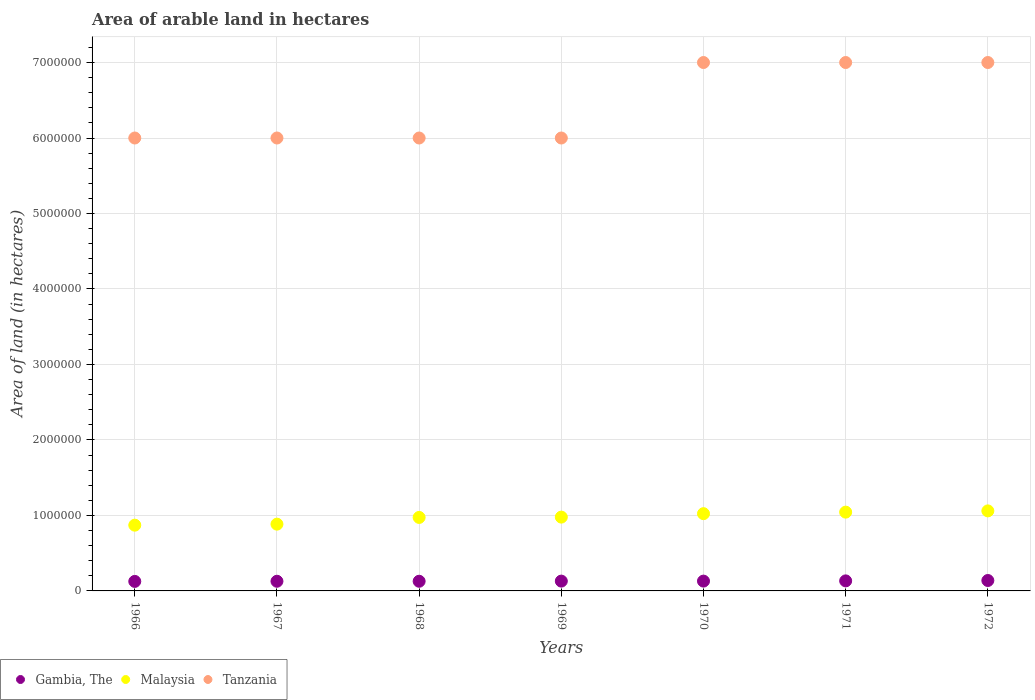How many different coloured dotlines are there?
Provide a short and direct response. 3. Is the number of dotlines equal to the number of legend labels?
Give a very brief answer. Yes. What is the total arable land in Tanzania in 1970?
Provide a succinct answer. 7.00e+06. Across all years, what is the maximum total arable land in Tanzania?
Offer a terse response. 7.00e+06. Across all years, what is the minimum total arable land in Malaysia?
Give a very brief answer. 8.71e+05. In which year was the total arable land in Gambia, The maximum?
Provide a succinct answer. 1972. In which year was the total arable land in Tanzania minimum?
Make the answer very short. 1966. What is the total total arable land in Malaysia in the graph?
Make the answer very short. 6.83e+06. What is the difference between the total arable land in Gambia, The in 1969 and that in 1971?
Keep it short and to the point. -3000. What is the difference between the total arable land in Gambia, The in 1967 and the total arable land in Tanzania in 1968?
Give a very brief answer. -5.87e+06. What is the average total arable land in Tanzania per year?
Ensure brevity in your answer.  6.43e+06. In the year 1971, what is the difference between the total arable land in Gambia, The and total arable land in Tanzania?
Your answer should be very brief. -6.87e+06. In how many years, is the total arable land in Gambia, The greater than 400000 hectares?
Offer a very short reply. 0. What is the ratio of the total arable land in Tanzania in 1968 to that in 1972?
Your answer should be compact. 0.86. Is the total arable land in Malaysia in 1967 less than that in 1971?
Offer a very short reply. Yes. Is the difference between the total arable land in Gambia, The in 1966 and 1971 greater than the difference between the total arable land in Tanzania in 1966 and 1971?
Give a very brief answer. Yes. What is the difference between the highest and the lowest total arable land in Malaysia?
Provide a short and direct response. 1.89e+05. In how many years, is the total arable land in Malaysia greater than the average total arable land in Malaysia taken over all years?
Ensure brevity in your answer.  4. Is it the case that in every year, the sum of the total arable land in Tanzania and total arable land in Malaysia  is greater than the total arable land in Gambia, The?
Your response must be concise. Yes. Is the total arable land in Malaysia strictly greater than the total arable land in Gambia, The over the years?
Provide a succinct answer. Yes. How many dotlines are there?
Give a very brief answer. 3. Does the graph contain any zero values?
Your response must be concise. No. Does the graph contain grids?
Keep it short and to the point. Yes. How are the legend labels stacked?
Provide a short and direct response. Horizontal. What is the title of the graph?
Make the answer very short. Area of arable land in hectares. What is the label or title of the X-axis?
Your answer should be compact. Years. What is the label or title of the Y-axis?
Ensure brevity in your answer.  Area of land (in hectares). What is the Area of land (in hectares) in Gambia, The in 1966?
Keep it short and to the point. 1.26e+05. What is the Area of land (in hectares) of Malaysia in 1966?
Keep it short and to the point. 8.71e+05. What is the Area of land (in hectares) in Tanzania in 1966?
Your response must be concise. 6.00e+06. What is the Area of land (in hectares) of Gambia, The in 1967?
Your answer should be compact. 1.28e+05. What is the Area of land (in hectares) in Malaysia in 1967?
Provide a succinct answer. 8.84e+05. What is the Area of land (in hectares) of Tanzania in 1967?
Your answer should be very brief. 6.00e+06. What is the Area of land (in hectares) of Gambia, The in 1968?
Your answer should be compact. 1.28e+05. What is the Area of land (in hectares) in Malaysia in 1968?
Your answer should be compact. 9.74e+05. What is the Area of land (in hectares) of Malaysia in 1969?
Ensure brevity in your answer.  9.78e+05. What is the Area of land (in hectares) of Gambia, The in 1970?
Offer a terse response. 1.30e+05. What is the Area of land (in hectares) in Malaysia in 1970?
Make the answer very short. 1.02e+06. What is the Area of land (in hectares) in Gambia, The in 1971?
Your answer should be compact. 1.33e+05. What is the Area of land (in hectares) in Malaysia in 1971?
Offer a very short reply. 1.04e+06. What is the Area of land (in hectares) in Gambia, The in 1972?
Give a very brief answer. 1.38e+05. What is the Area of land (in hectares) of Malaysia in 1972?
Give a very brief answer. 1.06e+06. Across all years, what is the maximum Area of land (in hectares) of Gambia, The?
Your answer should be compact. 1.38e+05. Across all years, what is the maximum Area of land (in hectares) of Malaysia?
Make the answer very short. 1.06e+06. Across all years, what is the maximum Area of land (in hectares) of Tanzania?
Give a very brief answer. 7.00e+06. Across all years, what is the minimum Area of land (in hectares) of Gambia, The?
Provide a succinct answer. 1.26e+05. Across all years, what is the minimum Area of land (in hectares) in Malaysia?
Keep it short and to the point. 8.71e+05. What is the total Area of land (in hectares) in Gambia, The in the graph?
Ensure brevity in your answer.  9.13e+05. What is the total Area of land (in hectares) of Malaysia in the graph?
Offer a terse response. 6.83e+06. What is the total Area of land (in hectares) in Tanzania in the graph?
Your response must be concise. 4.50e+07. What is the difference between the Area of land (in hectares) of Gambia, The in 1966 and that in 1967?
Ensure brevity in your answer.  -2000. What is the difference between the Area of land (in hectares) of Malaysia in 1966 and that in 1967?
Provide a succinct answer. -1.34e+04. What is the difference between the Area of land (in hectares) of Tanzania in 1966 and that in 1967?
Your answer should be very brief. 0. What is the difference between the Area of land (in hectares) of Gambia, The in 1966 and that in 1968?
Make the answer very short. -2000. What is the difference between the Area of land (in hectares) of Malaysia in 1966 and that in 1968?
Your response must be concise. -1.02e+05. What is the difference between the Area of land (in hectares) in Gambia, The in 1966 and that in 1969?
Offer a terse response. -4000. What is the difference between the Area of land (in hectares) in Malaysia in 1966 and that in 1969?
Provide a succinct answer. -1.07e+05. What is the difference between the Area of land (in hectares) of Tanzania in 1966 and that in 1969?
Offer a terse response. 0. What is the difference between the Area of land (in hectares) of Gambia, The in 1966 and that in 1970?
Make the answer very short. -4000. What is the difference between the Area of land (in hectares) of Malaysia in 1966 and that in 1970?
Offer a terse response. -1.52e+05. What is the difference between the Area of land (in hectares) in Gambia, The in 1966 and that in 1971?
Provide a short and direct response. -7000. What is the difference between the Area of land (in hectares) in Malaysia in 1966 and that in 1971?
Offer a very short reply. -1.73e+05. What is the difference between the Area of land (in hectares) of Gambia, The in 1966 and that in 1972?
Ensure brevity in your answer.  -1.20e+04. What is the difference between the Area of land (in hectares) in Malaysia in 1966 and that in 1972?
Ensure brevity in your answer.  -1.89e+05. What is the difference between the Area of land (in hectares) in Malaysia in 1967 and that in 1968?
Your answer should be very brief. -8.91e+04. What is the difference between the Area of land (in hectares) of Gambia, The in 1967 and that in 1969?
Provide a short and direct response. -2000. What is the difference between the Area of land (in hectares) in Malaysia in 1967 and that in 1969?
Your response must be concise. -9.33e+04. What is the difference between the Area of land (in hectares) in Gambia, The in 1967 and that in 1970?
Give a very brief answer. -2000. What is the difference between the Area of land (in hectares) of Malaysia in 1967 and that in 1970?
Provide a succinct answer. -1.39e+05. What is the difference between the Area of land (in hectares) in Gambia, The in 1967 and that in 1971?
Your answer should be compact. -5000. What is the difference between the Area of land (in hectares) in Malaysia in 1967 and that in 1971?
Ensure brevity in your answer.  -1.59e+05. What is the difference between the Area of land (in hectares) of Tanzania in 1967 and that in 1971?
Your response must be concise. -1.00e+06. What is the difference between the Area of land (in hectares) in Malaysia in 1967 and that in 1972?
Your response must be concise. -1.76e+05. What is the difference between the Area of land (in hectares) of Gambia, The in 1968 and that in 1969?
Ensure brevity in your answer.  -2000. What is the difference between the Area of land (in hectares) of Malaysia in 1968 and that in 1969?
Keep it short and to the point. -4200. What is the difference between the Area of land (in hectares) of Gambia, The in 1968 and that in 1970?
Ensure brevity in your answer.  -2000. What is the difference between the Area of land (in hectares) of Malaysia in 1968 and that in 1970?
Provide a succinct answer. -4.98e+04. What is the difference between the Area of land (in hectares) of Tanzania in 1968 and that in 1970?
Provide a short and direct response. -1.00e+06. What is the difference between the Area of land (in hectares) in Gambia, The in 1968 and that in 1971?
Offer a very short reply. -5000. What is the difference between the Area of land (in hectares) in Malaysia in 1968 and that in 1971?
Provide a succinct answer. -7.01e+04. What is the difference between the Area of land (in hectares) in Malaysia in 1968 and that in 1972?
Your answer should be very brief. -8.66e+04. What is the difference between the Area of land (in hectares) of Tanzania in 1968 and that in 1972?
Provide a short and direct response. -1.00e+06. What is the difference between the Area of land (in hectares) in Gambia, The in 1969 and that in 1970?
Keep it short and to the point. 0. What is the difference between the Area of land (in hectares) of Malaysia in 1969 and that in 1970?
Your answer should be compact. -4.56e+04. What is the difference between the Area of land (in hectares) in Tanzania in 1969 and that in 1970?
Make the answer very short. -1.00e+06. What is the difference between the Area of land (in hectares) in Gambia, The in 1969 and that in 1971?
Your response must be concise. -3000. What is the difference between the Area of land (in hectares) of Malaysia in 1969 and that in 1971?
Provide a succinct answer. -6.59e+04. What is the difference between the Area of land (in hectares) of Gambia, The in 1969 and that in 1972?
Make the answer very short. -8000. What is the difference between the Area of land (in hectares) of Malaysia in 1969 and that in 1972?
Offer a terse response. -8.24e+04. What is the difference between the Area of land (in hectares) in Gambia, The in 1970 and that in 1971?
Give a very brief answer. -3000. What is the difference between the Area of land (in hectares) of Malaysia in 1970 and that in 1971?
Provide a short and direct response. -2.03e+04. What is the difference between the Area of land (in hectares) in Gambia, The in 1970 and that in 1972?
Your answer should be compact. -8000. What is the difference between the Area of land (in hectares) of Malaysia in 1970 and that in 1972?
Your response must be concise. -3.68e+04. What is the difference between the Area of land (in hectares) of Gambia, The in 1971 and that in 1972?
Keep it short and to the point. -5000. What is the difference between the Area of land (in hectares) in Malaysia in 1971 and that in 1972?
Provide a succinct answer. -1.65e+04. What is the difference between the Area of land (in hectares) of Gambia, The in 1966 and the Area of land (in hectares) of Malaysia in 1967?
Offer a very short reply. -7.58e+05. What is the difference between the Area of land (in hectares) in Gambia, The in 1966 and the Area of land (in hectares) in Tanzania in 1967?
Your answer should be very brief. -5.87e+06. What is the difference between the Area of land (in hectares) of Malaysia in 1966 and the Area of land (in hectares) of Tanzania in 1967?
Your response must be concise. -5.13e+06. What is the difference between the Area of land (in hectares) in Gambia, The in 1966 and the Area of land (in hectares) in Malaysia in 1968?
Provide a succinct answer. -8.48e+05. What is the difference between the Area of land (in hectares) of Gambia, The in 1966 and the Area of land (in hectares) of Tanzania in 1968?
Ensure brevity in your answer.  -5.87e+06. What is the difference between the Area of land (in hectares) of Malaysia in 1966 and the Area of land (in hectares) of Tanzania in 1968?
Ensure brevity in your answer.  -5.13e+06. What is the difference between the Area of land (in hectares) in Gambia, The in 1966 and the Area of land (in hectares) in Malaysia in 1969?
Your answer should be very brief. -8.52e+05. What is the difference between the Area of land (in hectares) of Gambia, The in 1966 and the Area of land (in hectares) of Tanzania in 1969?
Keep it short and to the point. -5.87e+06. What is the difference between the Area of land (in hectares) of Malaysia in 1966 and the Area of land (in hectares) of Tanzania in 1969?
Your answer should be very brief. -5.13e+06. What is the difference between the Area of land (in hectares) of Gambia, The in 1966 and the Area of land (in hectares) of Malaysia in 1970?
Provide a short and direct response. -8.97e+05. What is the difference between the Area of land (in hectares) of Gambia, The in 1966 and the Area of land (in hectares) of Tanzania in 1970?
Offer a very short reply. -6.87e+06. What is the difference between the Area of land (in hectares) in Malaysia in 1966 and the Area of land (in hectares) in Tanzania in 1970?
Give a very brief answer. -6.13e+06. What is the difference between the Area of land (in hectares) in Gambia, The in 1966 and the Area of land (in hectares) in Malaysia in 1971?
Offer a terse response. -9.18e+05. What is the difference between the Area of land (in hectares) in Gambia, The in 1966 and the Area of land (in hectares) in Tanzania in 1971?
Make the answer very short. -6.87e+06. What is the difference between the Area of land (in hectares) of Malaysia in 1966 and the Area of land (in hectares) of Tanzania in 1971?
Provide a succinct answer. -6.13e+06. What is the difference between the Area of land (in hectares) in Gambia, The in 1966 and the Area of land (in hectares) in Malaysia in 1972?
Ensure brevity in your answer.  -9.34e+05. What is the difference between the Area of land (in hectares) of Gambia, The in 1966 and the Area of land (in hectares) of Tanzania in 1972?
Provide a succinct answer. -6.87e+06. What is the difference between the Area of land (in hectares) of Malaysia in 1966 and the Area of land (in hectares) of Tanzania in 1972?
Keep it short and to the point. -6.13e+06. What is the difference between the Area of land (in hectares) in Gambia, The in 1967 and the Area of land (in hectares) in Malaysia in 1968?
Give a very brief answer. -8.46e+05. What is the difference between the Area of land (in hectares) of Gambia, The in 1967 and the Area of land (in hectares) of Tanzania in 1968?
Provide a succinct answer. -5.87e+06. What is the difference between the Area of land (in hectares) in Malaysia in 1967 and the Area of land (in hectares) in Tanzania in 1968?
Make the answer very short. -5.12e+06. What is the difference between the Area of land (in hectares) in Gambia, The in 1967 and the Area of land (in hectares) in Malaysia in 1969?
Offer a very short reply. -8.50e+05. What is the difference between the Area of land (in hectares) of Gambia, The in 1967 and the Area of land (in hectares) of Tanzania in 1969?
Your response must be concise. -5.87e+06. What is the difference between the Area of land (in hectares) in Malaysia in 1967 and the Area of land (in hectares) in Tanzania in 1969?
Your answer should be compact. -5.12e+06. What is the difference between the Area of land (in hectares) in Gambia, The in 1967 and the Area of land (in hectares) in Malaysia in 1970?
Provide a succinct answer. -8.95e+05. What is the difference between the Area of land (in hectares) in Gambia, The in 1967 and the Area of land (in hectares) in Tanzania in 1970?
Provide a short and direct response. -6.87e+06. What is the difference between the Area of land (in hectares) of Malaysia in 1967 and the Area of land (in hectares) of Tanzania in 1970?
Provide a succinct answer. -6.12e+06. What is the difference between the Area of land (in hectares) in Gambia, The in 1967 and the Area of land (in hectares) in Malaysia in 1971?
Provide a short and direct response. -9.16e+05. What is the difference between the Area of land (in hectares) of Gambia, The in 1967 and the Area of land (in hectares) of Tanzania in 1971?
Your response must be concise. -6.87e+06. What is the difference between the Area of land (in hectares) of Malaysia in 1967 and the Area of land (in hectares) of Tanzania in 1971?
Your response must be concise. -6.12e+06. What is the difference between the Area of land (in hectares) of Gambia, The in 1967 and the Area of land (in hectares) of Malaysia in 1972?
Provide a succinct answer. -9.32e+05. What is the difference between the Area of land (in hectares) in Gambia, The in 1967 and the Area of land (in hectares) in Tanzania in 1972?
Provide a short and direct response. -6.87e+06. What is the difference between the Area of land (in hectares) of Malaysia in 1967 and the Area of land (in hectares) of Tanzania in 1972?
Offer a very short reply. -6.12e+06. What is the difference between the Area of land (in hectares) in Gambia, The in 1968 and the Area of land (in hectares) in Malaysia in 1969?
Your answer should be compact. -8.50e+05. What is the difference between the Area of land (in hectares) of Gambia, The in 1968 and the Area of land (in hectares) of Tanzania in 1969?
Your answer should be compact. -5.87e+06. What is the difference between the Area of land (in hectares) of Malaysia in 1968 and the Area of land (in hectares) of Tanzania in 1969?
Your answer should be compact. -5.03e+06. What is the difference between the Area of land (in hectares) of Gambia, The in 1968 and the Area of land (in hectares) of Malaysia in 1970?
Offer a terse response. -8.95e+05. What is the difference between the Area of land (in hectares) of Gambia, The in 1968 and the Area of land (in hectares) of Tanzania in 1970?
Offer a terse response. -6.87e+06. What is the difference between the Area of land (in hectares) in Malaysia in 1968 and the Area of land (in hectares) in Tanzania in 1970?
Your answer should be compact. -6.03e+06. What is the difference between the Area of land (in hectares) in Gambia, The in 1968 and the Area of land (in hectares) in Malaysia in 1971?
Your response must be concise. -9.16e+05. What is the difference between the Area of land (in hectares) of Gambia, The in 1968 and the Area of land (in hectares) of Tanzania in 1971?
Your answer should be compact. -6.87e+06. What is the difference between the Area of land (in hectares) of Malaysia in 1968 and the Area of land (in hectares) of Tanzania in 1971?
Your answer should be very brief. -6.03e+06. What is the difference between the Area of land (in hectares) of Gambia, The in 1968 and the Area of land (in hectares) of Malaysia in 1972?
Provide a short and direct response. -9.32e+05. What is the difference between the Area of land (in hectares) of Gambia, The in 1968 and the Area of land (in hectares) of Tanzania in 1972?
Provide a succinct answer. -6.87e+06. What is the difference between the Area of land (in hectares) in Malaysia in 1968 and the Area of land (in hectares) in Tanzania in 1972?
Offer a terse response. -6.03e+06. What is the difference between the Area of land (in hectares) of Gambia, The in 1969 and the Area of land (in hectares) of Malaysia in 1970?
Provide a short and direct response. -8.93e+05. What is the difference between the Area of land (in hectares) in Gambia, The in 1969 and the Area of land (in hectares) in Tanzania in 1970?
Provide a succinct answer. -6.87e+06. What is the difference between the Area of land (in hectares) in Malaysia in 1969 and the Area of land (in hectares) in Tanzania in 1970?
Your answer should be compact. -6.02e+06. What is the difference between the Area of land (in hectares) of Gambia, The in 1969 and the Area of land (in hectares) of Malaysia in 1971?
Keep it short and to the point. -9.14e+05. What is the difference between the Area of land (in hectares) of Gambia, The in 1969 and the Area of land (in hectares) of Tanzania in 1971?
Offer a terse response. -6.87e+06. What is the difference between the Area of land (in hectares) in Malaysia in 1969 and the Area of land (in hectares) in Tanzania in 1971?
Ensure brevity in your answer.  -6.02e+06. What is the difference between the Area of land (in hectares) in Gambia, The in 1969 and the Area of land (in hectares) in Malaysia in 1972?
Provide a succinct answer. -9.30e+05. What is the difference between the Area of land (in hectares) in Gambia, The in 1969 and the Area of land (in hectares) in Tanzania in 1972?
Give a very brief answer. -6.87e+06. What is the difference between the Area of land (in hectares) of Malaysia in 1969 and the Area of land (in hectares) of Tanzania in 1972?
Provide a short and direct response. -6.02e+06. What is the difference between the Area of land (in hectares) in Gambia, The in 1970 and the Area of land (in hectares) in Malaysia in 1971?
Your answer should be compact. -9.14e+05. What is the difference between the Area of land (in hectares) of Gambia, The in 1970 and the Area of land (in hectares) of Tanzania in 1971?
Provide a succinct answer. -6.87e+06. What is the difference between the Area of land (in hectares) of Malaysia in 1970 and the Area of land (in hectares) of Tanzania in 1971?
Ensure brevity in your answer.  -5.98e+06. What is the difference between the Area of land (in hectares) of Gambia, The in 1970 and the Area of land (in hectares) of Malaysia in 1972?
Offer a very short reply. -9.30e+05. What is the difference between the Area of land (in hectares) of Gambia, The in 1970 and the Area of land (in hectares) of Tanzania in 1972?
Your response must be concise. -6.87e+06. What is the difference between the Area of land (in hectares) of Malaysia in 1970 and the Area of land (in hectares) of Tanzania in 1972?
Give a very brief answer. -5.98e+06. What is the difference between the Area of land (in hectares) of Gambia, The in 1971 and the Area of land (in hectares) of Malaysia in 1972?
Keep it short and to the point. -9.27e+05. What is the difference between the Area of land (in hectares) in Gambia, The in 1971 and the Area of land (in hectares) in Tanzania in 1972?
Your answer should be very brief. -6.87e+06. What is the difference between the Area of land (in hectares) of Malaysia in 1971 and the Area of land (in hectares) of Tanzania in 1972?
Your answer should be compact. -5.96e+06. What is the average Area of land (in hectares) of Gambia, The per year?
Your answer should be very brief. 1.30e+05. What is the average Area of land (in hectares) in Malaysia per year?
Your answer should be very brief. 9.76e+05. What is the average Area of land (in hectares) in Tanzania per year?
Make the answer very short. 6.43e+06. In the year 1966, what is the difference between the Area of land (in hectares) in Gambia, The and Area of land (in hectares) in Malaysia?
Offer a very short reply. -7.45e+05. In the year 1966, what is the difference between the Area of land (in hectares) of Gambia, The and Area of land (in hectares) of Tanzania?
Keep it short and to the point. -5.87e+06. In the year 1966, what is the difference between the Area of land (in hectares) of Malaysia and Area of land (in hectares) of Tanzania?
Offer a very short reply. -5.13e+06. In the year 1967, what is the difference between the Area of land (in hectares) of Gambia, The and Area of land (in hectares) of Malaysia?
Offer a very short reply. -7.56e+05. In the year 1967, what is the difference between the Area of land (in hectares) of Gambia, The and Area of land (in hectares) of Tanzania?
Ensure brevity in your answer.  -5.87e+06. In the year 1967, what is the difference between the Area of land (in hectares) of Malaysia and Area of land (in hectares) of Tanzania?
Provide a short and direct response. -5.12e+06. In the year 1968, what is the difference between the Area of land (in hectares) of Gambia, The and Area of land (in hectares) of Malaysia?
Provide a succinct answer. -8.46e+05. In the year 1968, what is the difference between the Area of land (in hectares) of Gambia, The and Area of land (in hectares) of Tanzania?
Your answer should be compact. -5.87e+06. In the year 1968, what is the difference between the Area of land (in hectares) in Malaysia and Area of land (in hectares) in Tanzania?
Ensure brevity in your answer.  -5.03e+06. In the year 1969, what is the difference between the Area of land (in hectares) in Gambia, The and Area of land (in hectares) in Malaysia?
Your answer should be very brief. -8.48e+05. In the year 1969, what is the difference between the Area of land (in hectares) of Gambia, The and Area of land (in hectares) of Tanzania?
Make the answer very short. -5.87e+06. In the year 1969, what is the difference between the Area of land (in hectares) of Malaysia and Area of land (in hectares) of Tanzania?
Ensure brevity in your answer.  -5.02e+06. In the year 1970, what is the difference between the Area of land (in hectares) in Gambia, The and Area of land (in hectares) in Malaysia?
Keep it short and to the point. -8.93e+05. In the year 1970, what is the difference between the Area of land (in hectares) of Gambia, The and Area of land (in hectares) of Tanzania?
Make the answer very short. -6.87e+06. In the year 1970, what is the difference between the Area of land (in hectares) in Malaysia and Area of land (in hectares) in Tanzania?
Provide a succinct answer. -5.98e+06. In the year 1971, what is the difference between the Area of land (in hectares) in Gambia, The and Area of land (in hectares) in Malaysia?
Your answer should be very brief. -9.11e+05. In the year 1971, what is the difference between the Area of land (in hectares) in Gambia, The and Area of land (in hectares) in Tanzania?
Your answer should be compact. -6.87e+06. In the year 1971, what is the difference between the Area of land (in hectares) in Malaysia and Area of land (in hectares) in Tanzania?
Provide a succinct answer. -5.96e+06. In the year 1972, what is the difference between the Area of land (in hectares) of Gambia, The and Area of land (in hectares) of Malaysia?
Your answer should be very brief. -9.22e+05. In the year 1972, what is the difference between the Area of land (in hectares) of Gambia, The and Area of land (in hectares) of Tanzania?
Provide a succinct answer. -6.86e+06. In the year 1972, what is the difference between the Area of land (in hectares) in Malaysia and Area of land (in hectares) in Tanzania?
Your answer should be compact. -5.94e+06. What is the ratio of the Area of land (in hectares) of Gambia, The in 1966 to that in 1967?
Offer a terse response. 0.98. What is the ratio of the Area of land (in hectares) in Malaysia in 1966 to that in 1967?
Give a very brief answer. 0.98. What is the ratio of the Area of land (in hectares) in Gambia, The in 1966 to that in 1968?
Provide a succinct answer. 0.98. What is the ratio of the Area of land (in hectares) in Malaysia in 1966 to that in 1968?
Offer a very short reply. 0.89. What is the ratio of the Area of land (in hectares) in Gambia, The in 1966 to that in 1969?
Provide a short and direct response. 0.97. What is the ratio of the Area of land (in hectares) in Malaysia in 1966 to that in 1969?
Keep it short and to the point. 0.89. What is the ratio of the Area of land (in hectares) in Tanzania in 1966 to that in 1969?
Offer a very short reply. 1. What is the ratio of the Area of land (in hectares) in Gambia, The in 1966 to that in 1970?
Ensure brevity in your answer.  0.97. What is the ratio of the Area of land (in hectares) in Malaysia in 1966 to that in 1970?
Make the answer very short. 0.85. What is the ratio of the Area of land (in hectares) in Gambia, The in 1966 to that in 1971?
Keep it short and to the point. 0.95. What is the ratio of the Area of land (in hectares) in Malaysia in 1966 to that in 1971?
Your answer should be very brief. 0.83. What is the ratio of the Area of land (in hectares) in Tanzania in 1966 to that in 1971?
Provide a short and direct response. 0.86. What is the ratio of the Area of land (in hectares) of Gambia, The in 1966 to that in 1972?
Make the answer very short. 0.91. What is the ratio of the Area of land (in hectares) in Malaysia in 1966 to that in 1972?
Provide a succinct answer. 0.82. What is the ratio of the Area of land (in hectares) in Gambia, The in 1967 to that in 1968?
Make the answer very short. 1. What is the ratio of the Area of land (in hectares) of Malaysia in 1967 to that in 1968?
Ensure brevity in your answer.  0.91. What is the ratio of the Area of land (in hectares) in Tanzania in 1967 to that in 1968?
Your answer should be very brief. 1. What is the ratio of the Area of land (in hectares) in Gambia, The in 1967 to that in 1969?
Ensure brevity in your answer.  0.98. What is the ratio of the Area of land (in hectares) in Malaysia in 1967 to that in 1969?
Your response must be concise. 0.9. What is the ratio of the Area of land (in hectares) in Tanzania in 1967 to that in 1969?
Offer a very short reply. 1. What is the ratio of the Area of land (in hectares) in Gambia, The in 1967 to that in 1970?
Make the answer very short. 0.98. What is the ratio of the Area of land (in hectares) of Malaysia in 1967 to that in 1970?
Keep it short and to the point. 0.86. What is the ratio of the Area of land (in hectares) of Gambia, The in 1967 to that in 1971?
Ensure brevity in your answer.  0.96. What is the ratio of the Area of land (in hectares) of Malaysia in 1967 to that in 1971?
Give a very brief answer. 0.85. What is the ratio of the Area of land (in hectares) in Gambia, The in 1967 to that in 1972?
Your answer should be very brief. 0.93. What is the ratio of the Area of land (in hectares) of Malaysia in 1967 to that in 1972?
Ensure brevity in your answer.  0.83. What is the ratio of the Area of land (in hectares) in Gambia, The in 1968 to that in 1969?
Offer a terse response. 0.98. What is the ratio of the Area of land (in hectares) of Gambia, The in 1968 to that in 1970?
Your answer should be compact. 0.98. What is the ratio of the Area of land (in hectares) of Malaysia in 1968 to that in 1970?
Offer a terse response. 0.95. What is the ratio of the Area of land (in hectares) of Gambia, The in 1968 to that in 1971?
Your answer should be compact. 0.96. What is the ratio of the Area of land (in hectares) of Malaysia in 1968 to that in 1971?
Ensure brevity in your answer.  0.93. What is the ratio of the Area of land (in hectares) in Tanzania in 1968 to that in 1971?
Make the answer very short. 0.86. What is the ratio of the Area of land (in hectares) of Gambia, The in 1968 to that in 1972?
Your answer should be compact. 0.93. What is the ratio of the Area of land (in hectares) of Malaysia in 1968 to that in 1972?
Keep it short and to the point. 0.92. What is the ratio of the Area of land (in hectares) in Tanzania in 1968 to that in 1972?
Keep it short and to the point. 0.86. What is the ratio of the Area of land (in hectares) of Malaysia in 1969 to that in 1970?
Provide a succinct answer. 0.96. What is the ratio of the Area of land (in hectares) in Tanzania in 1969 to that in 1970?
Your response must be concise. 0.86. What is the ratio of the Area of land (in hectares) of Gambia, The in 1969 to that in 1971?
Your answer should be compact. 0.98. What is the ratio of the Area of land (in hectares) in Malaysia in 1969 to that in 1971?
Your answer should be very brief. 0.94. What is the ratio of the Area of land (in hectares) in Gambia, The in 1969 to that in 1972?
Make the answer very short. 0.94. What is the ratio of the Area of land (in hectares) in Malaysia in 1969 to that in 1972?
Provide a short and direct response. 0.92. What is the ratio of the Area of land (in hectares) in Gambia, The in 1970 to that in 1971?
Offer a very short reply. 0.98. What is the ratio of the Area of land (in hectares) of Malaysia in 1970 to that in 1971?
Your answer should be compact. 0.98. What is the ratio of the Area of land (in hectares) in Tanzania in 1970 to that in 1971?
Offer a terse response. 1. What is the ratio of the Area of land (in hectares) in Gambia, The in 1970 to that in 1972?
Provide a succinct answer. 0.94. What is the ratio of the Area of land (in hectares) of Malaysia in 1970 to that in 1972?
Your answer should be compact. 0.97. What is the ratio of the Area of land (in hectares) in Gambia, The in 1971 to that in 1972?
Provide a succinct answer. 0.96. What is the ratio of the Area of land (in hectares) in Malaysia in 1971 to that in 1972?
Keep it short and to the point. 0.98. What is the ratio of the Area of land (in hectares) of Tanzania in 1971 to that in 1972?
Provide a succinct answer. 1. What is the difference between the highest and the second highest Area of land (in hectares) in Malaysia?
Your answer should be compact. 1.65e+04. What is the difference between the highest and the lowest Area of land (in hectares) in Gambia, The?
Provide a succinct answer. 1.20e+04. What is the difference between the highest and the lowest Area of land (in hectares) in Malaysia?
Make the answer very short. 1.89e+05. 